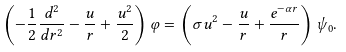Convert formula to latex. <formula><loc_0><loc_0><loc_500><loc_500>\left ( - \frac { 1 } { 2 } \frac { d ^ { 2 } } { d r ^ { 2 } } - \frac { u } { r } + \frac { u ^ { 2 } } { 2 } \right ) \varphi = \left ( \sigma u ^ { 2 } - \frac { u } { r } + \frac { e ^ { - \alpha r } } { r } \right ) \psi _ { 0 } .</formula> 